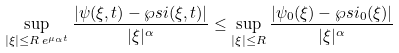<formula> <loc_0><loc_0><loc_500><loc_500>\sup _ { | \xi | \leq R \, e ^ { \mu _ { \alpha } t } } \frac { | \psi ( \xi , t ) - \wp s i ( \xi , t ) | } { | \xi | ^ { \alpha } } \leq \sup _ { | \xi | \leq R } \frac { | \psi _ { 0 } ( \xi ) - \wp s i _ { 0 } ( \xi ) | } { | \xi | ^ { \alpha } }</formula> 